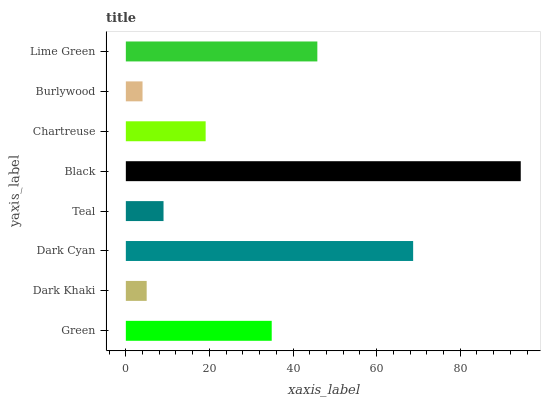Is Burlywood the minimum?
Answer yes or no. Yes. Is Black the maximum?
Answer yes or no. Yes. Is Dark Khaki the minimum?
Answer yes or no. No. Is Dark Khaki the maximum?
Answer yes or no. No. Is Green greater than Dark Khaki?
Answer yes or no. Yes. Is Dark Khaki less than Green?
Answer yes or no. Yes. Is Dark Khaki greater than Green?
Answer yes or no. No. Is Green less than Dark Khaki?
Answer yes or no. No. Is Green the high median?
Answer yes or no. Yes. Is Chartreuse the low median?
Answer yes or no. Yes. Is Black the high median?
Answer yes or no. No. Is Dark Khaki the low median?
Answer yes or no. No. 